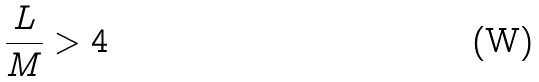Convert formula to latex. <formula><loc_0><loc_0><loc_500><loc_500>\frac { L } { M } > 4</formula> 